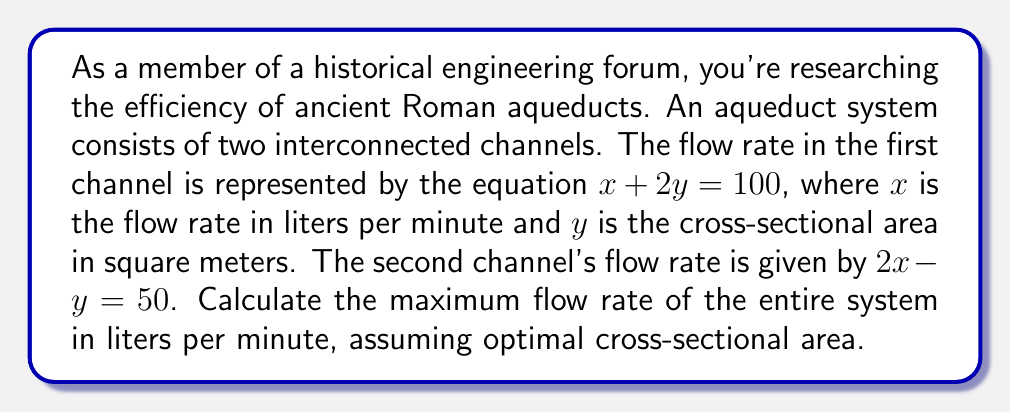Help me with this question. To solve this problem, we need to use a system of linear equations and find the point of intersection, which will give us the optimal values for $x$ (flow rate) and $y$ (cross-sectional area).

1) We have two equations:
   $$x + 2y = 100$$ (Equation 1)
   $$2x - y = 50$$ (Equation 2)

2) We can solve this system using substitution or elimination. Let's use elimination:
   Multiply Equation 1 by 2: $$2x + 4y = 200$$ (Equation 3)
   
3) Now subtract Equation 2 from Equation 3:
   $$(2x + 4y = 200) - (2x - y = 50)$$
   $$5y = 150$$

4) Solve for $y$:
   $$y = 30$$

5) Substitute this value of $y$ into Equation 1:
   $$x + 2(30) = 100$$
   $$x + 60 = 100$$
   $$x = 40$$

6) Therefore, the optimal flow rate ($x$) is 40 liters per minute, and the optimal cross-sectional area ($y$) is 30 square meters.

7) Since this represents the flow rate in one channel, we need to calculate the total flow rate for both channels:
   Total flow rate = $40 + 40 = 80$ liters per minute

This solution represents the maximum efficiency of the system, as it satisfies both equations simultaneously.
Answer: The maximum flow rate of the entire aqueduct system is 80 liters per minute. 